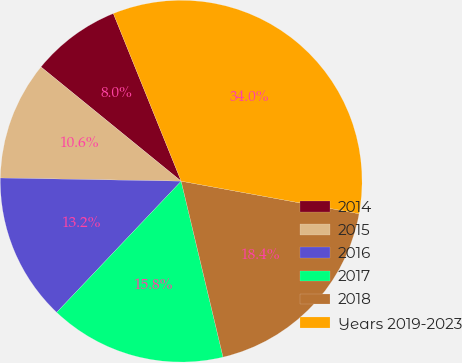<chart> <loc_0><loc_0><loc_500><loc_500><pie_chart><fcel>2014<fcel>2015<fcel>2016<fcel>2017<fcel>2018<fcel>Years 2019-2023<nl><fcel>8.0%<fcel>10.6%<fcel>13.2%<fcel>15.8%<fcel>18.4%<fcel>34.0%<nl></chart> 